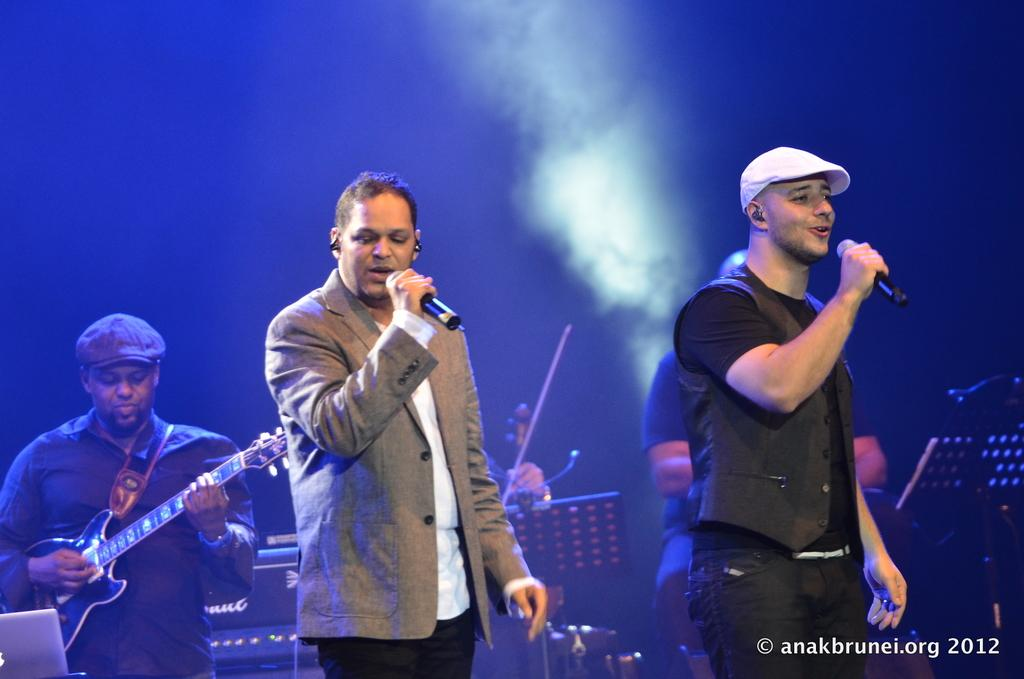What are the people in the image doing? The people in the image are playing musical instruments and singing. Can you describe the people holding microphones? Two people are holding microphones in the image. What can be seen on the head of the person on the right side? The person on the right side is wearing a cap. How many legs does the kitty have in the image? There is no kitty present in the image, so it is not possible to determine the number of legs. 